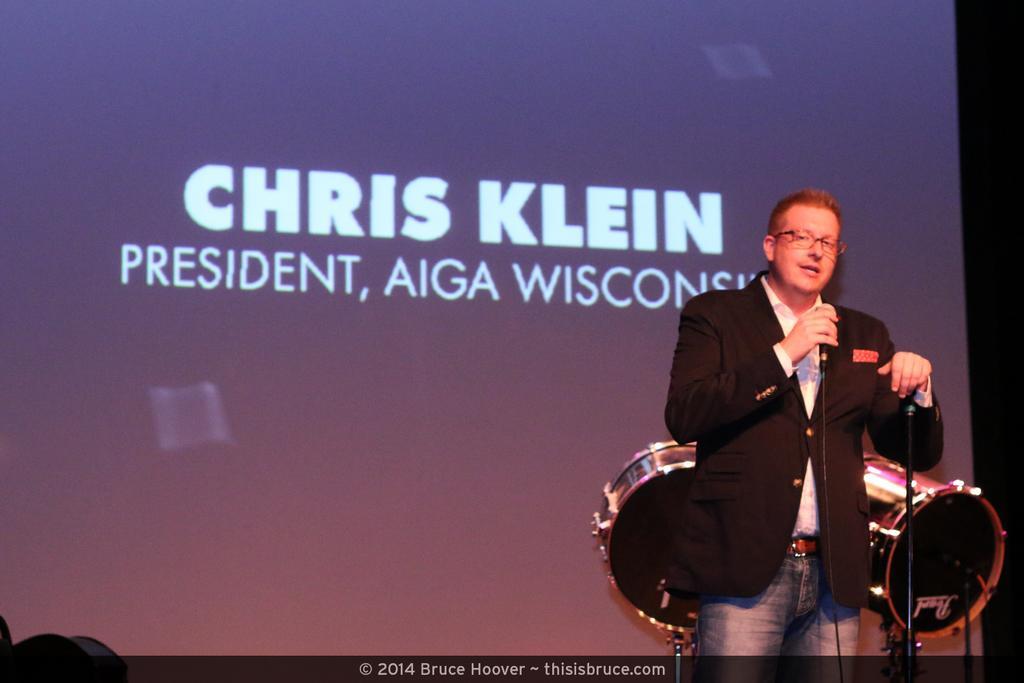Can you describe this image briefly? In this image we can see a person, microphone and stand. In the background of the image there is a screen and musical instrument. On the left side of the image there is an object. On the image there is a watermark. 